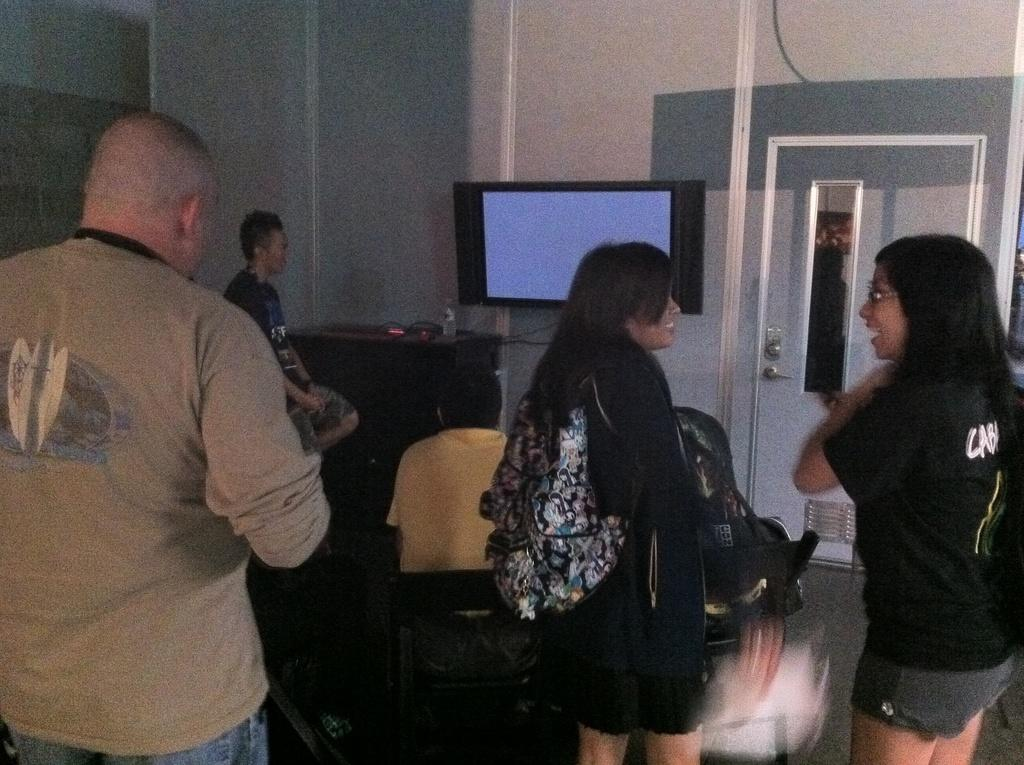What are the people in the room doing? There are people sitting and standing in the room. What furniture is present in the room? There is a table in the room. What electronic device is in the room? There is a TV in the room. Is there a way to enter or exit the room? Yes, there is a door in the room. Can you hear the toad laughing in the room? There is no toad present in the room, and therefore no such activity can be heard. 